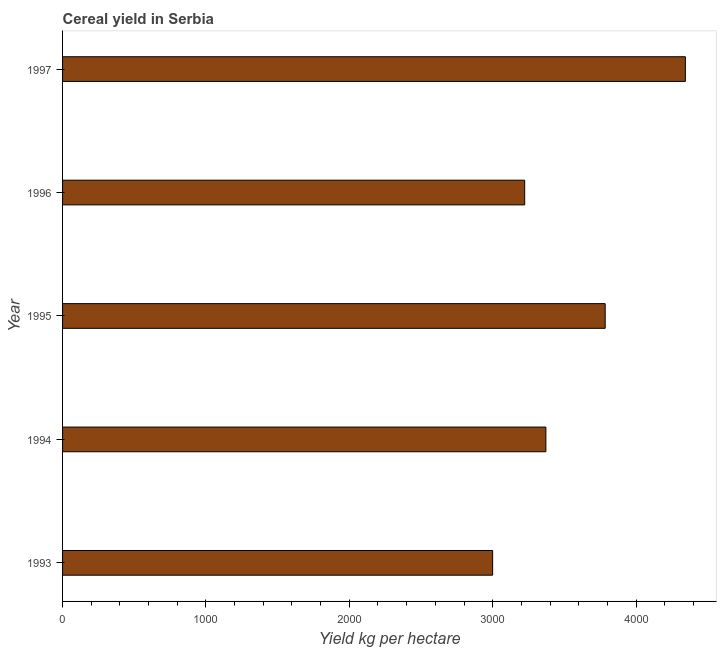Does the graph contain any zero values?
Keep it short and to the point. No. Does the graph contain grids?
Keep it short and to the point. No. What is the title of the graph?
Provide a short and direct response. Cereal yield in Serbia. What is the label or title of the X-axis?
Keep it short and to the point. Yield kg per hectare. What is the cereal yield in 1994?
Your answer should be compact. 3371.02. Across all years, what is the maximum cereal yield?
Provide a short and direct response. 4343.93. Across all years, what is the minimum cereal yield?
Provide a short and direct response. 2999.79. In which year was the cereal yield maximum?
Your answer should be compact. 1997. What is the sum of the cereal yield?
Offer a very short reply. 1.77e+04. What is the difference between the cereal yield in 1996 and 1997?
Your response must be concise. -1120.62. What is the average cereal yield per year?
Provide a succinct answer. 3544.56. What is the median cereal yield?
Ensure brevity in your answer.  3371.02. What is the ratio of the cereal yield in 1994 to that in 1996?
Your answer should be very brief. 1.05. What is the difference between the highest and the second highest cereal yield?
Offer a terse response. 559.16. What is the difference between the highest and the lowest cereal yield?
Ensure brevity in your answer.  1344.14. What is the difference between two consecutive major ticks on the X-axis?
Give a very brief answer. 1000. What is the Yield kg per hectare in 1993?
Your answer should be compact. 2999.79. What is the Yield kg per hectare in 1994?
Your answer should be compact. 3371.02. What is the Yield kg per hectare of 1995?
Provide a short and direct response. 3784.76. What is the Yield kg per hectare of 1996?
Provide a succinct answer. 3223.3. What is the Yield kg per hectare of 1997?
Your answer should be very brief. 4343.93. What is the difference between the Yield kg per hectare in 1993 and 1994?
Offer a terse response. -371.23. What is the difference between the Yield kg per hectare in 1993 and 1995?
Offer a very short reply. -784.98. What is the difference between the Yield kg per hectare in 1993 and 1996?
Your answer should be compact. -223.51. What is the difference between the Yield kg per hectare in 1993 and 1997?
Ensure brevity in your answer.  -1344.14. What is the difference between the Yield kg per hectare in 1994 and 1995?
Provide a short and direct response. -413.74. What is the difference between the Yield kg per hectare in 1994 and 1996?
Your answer should be compact. 147.72. What is the difference between the Yield kg per hectare in 1994 and 1997?
Provide a short and direct response. -972.9. What is the difference between the Yield kg per hectare in 1995 and 1996?
Offer a terse response. 561.46. What is the difference between the Yield kg per hectare in 1995 and 1997?
Ensure brevity in your answer.  -559.16. What is the difference between the Yield kg per hectare in 1996 and 1997?
Ensure brevity in your answer.  -1120.62. What is the ratio of the Yield kg per hectare in 1993 to that in 1994?
Offer a very short reply. 0.89. What is the ratio of the Yield kg per hectare in 1993 to that in 1995?
Provide a short and direct response. 0.79. What is the ratio of the Yield kg per hectare in 1993 to that in 1997?
Provide a succinct answer. 0.69. What is the ratio of the Yield kg per hectare in 1994 to that in 1995?
Ensure brevity in your answer.  0.89. What is the ratio of the Yield kg per hectare in 1994 to that in 1996?
Offer a terse response. 1.05. What is the ratio of the Yield kg per hectare in 1994 to that in 1997?
Offer a terse response. 0.78. What is the ratio of the Yield kg per hectare in 1995 to that in 1996?
Your response must be concise. 1.17. What is the ratio of the Yield kg per hectare in 1995 to that in 1997?
Provide a short and direct response. 0.87. What is the ratio of the Yield kg per hectare in 1996 to that in 1997?
Your answer should be compact. 0.74. 